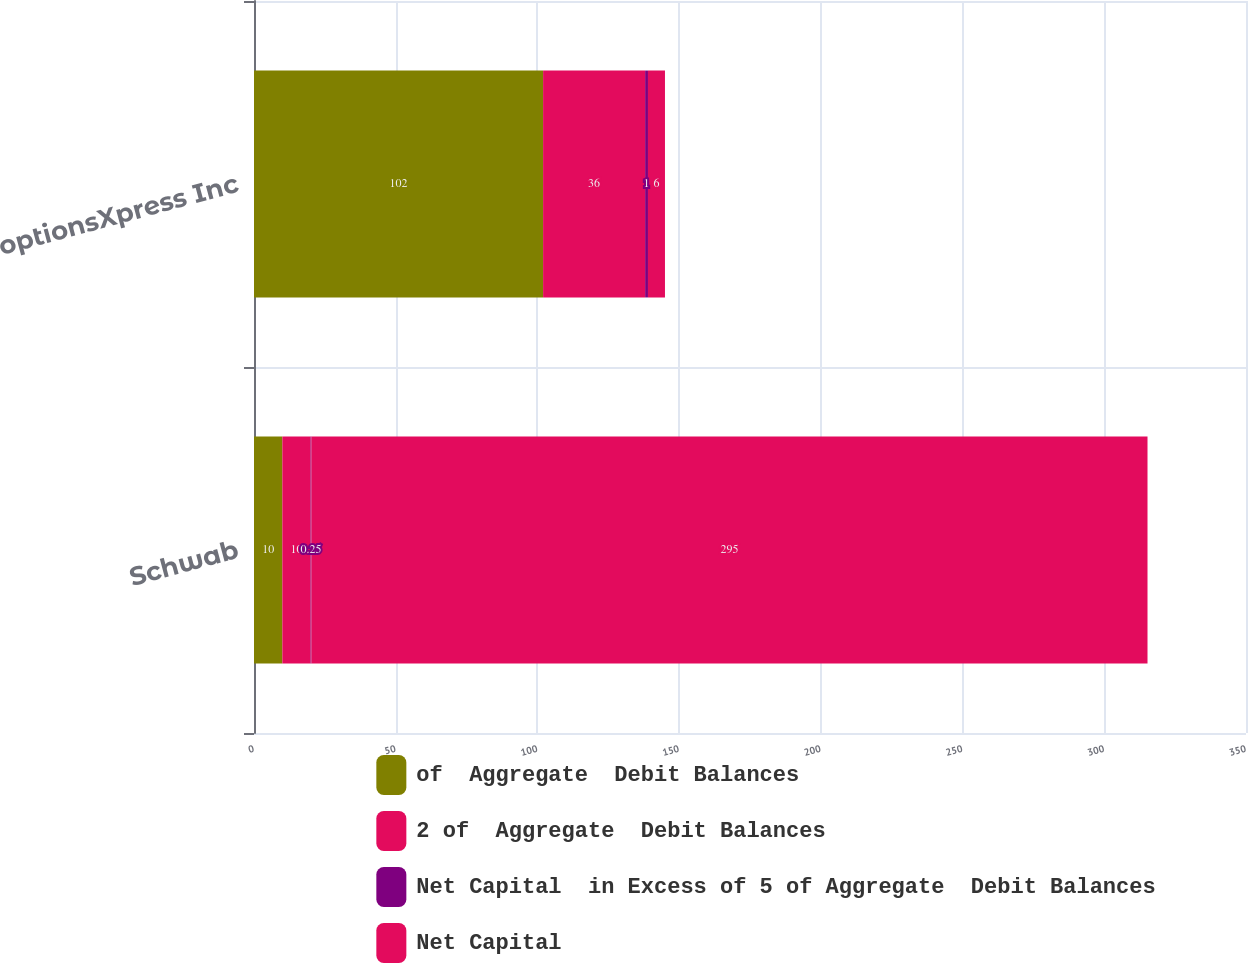Convert chart. <chart><loc_0><loc_0><loc_500><loc_500><stacked_bar_chart><ecel><fcel>Schwab<fcel>optionsXpress Inc<nl><fcel>of  Aggregate  Debit Balances<fcel>10<fcel>102<nl><fcel>2 of  Aggregate  Debit Balances<fcel>10<fcel>36<nl><fcel>Net Capital  in Excess of 5 of Aggregate  Debit Balances<fcel>0.25<fcel>1<nl><fcel>Net Capital<fcel>295<fcel>6<nl></chart> 